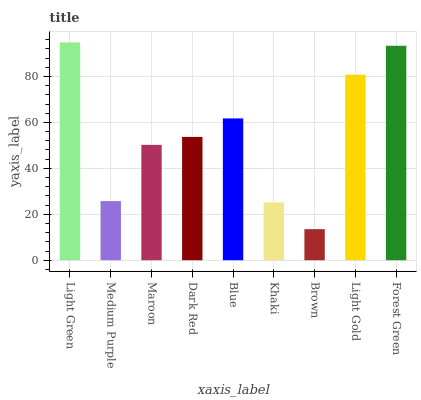Is Brown the minimum?
Answer yes or no. Yes. Is Light Green the maximum?
Answer yes or no. Yes. Is Medium Purple the minimum?
Answer yes or no. No. Is Medium Purple the maximum?
Answer yes or no. No. Is Light Green greater than Medium Purple?
Answer yes or no. Yes. Is Medium Purple less than Light Green?
Answer yes or no. Yes. Is Medium Purple greater than Light Green?
Answer yes or no. No. Is Light Green less than Medium Purple?
Answer yes or no. No. Is Dark Red the high median?
Answer yes or no. Yes. Is Dark Red the low median?
Answer yes or no. Yes. Is Khaki the high median?
Answer yes or no. No. Is Light Gold the low median?
Answer yes or no. No. 